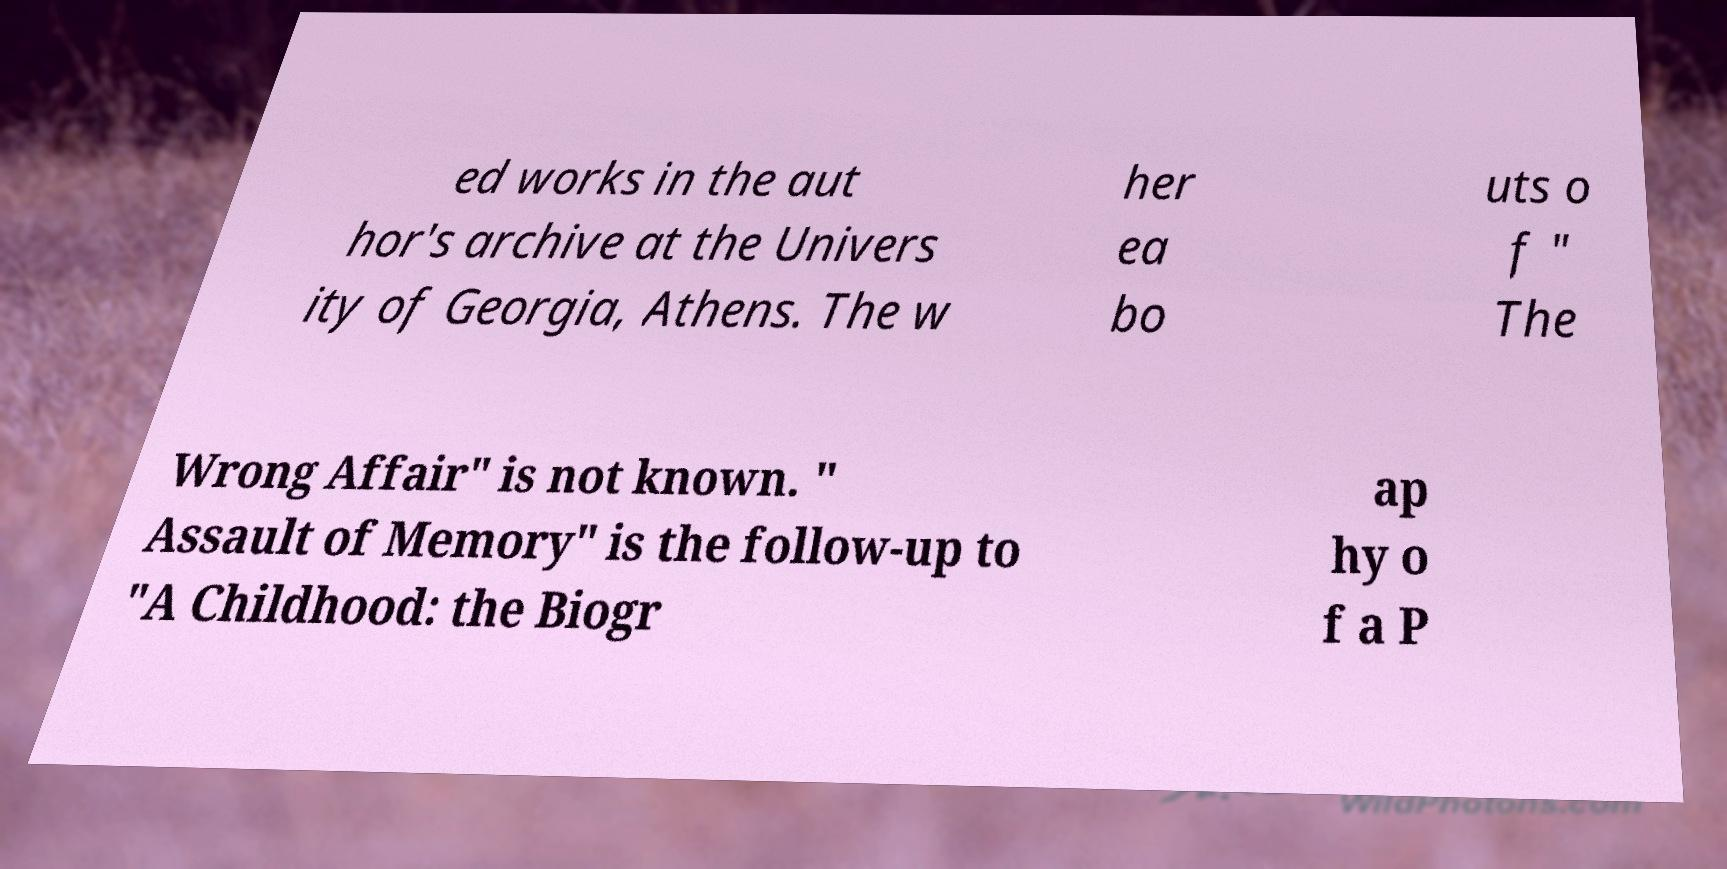For documentation purposes, I need the text within this image transcribed. Could you provide that? ed works in the aut hor's archive at the Univers ity of Georgia, Athens. The w her ea bo uts o f " The Wrong Affair" is not known. " Assault of Memory" is the follow-up to "A Childhood: the Biogr ap hy o f a P 